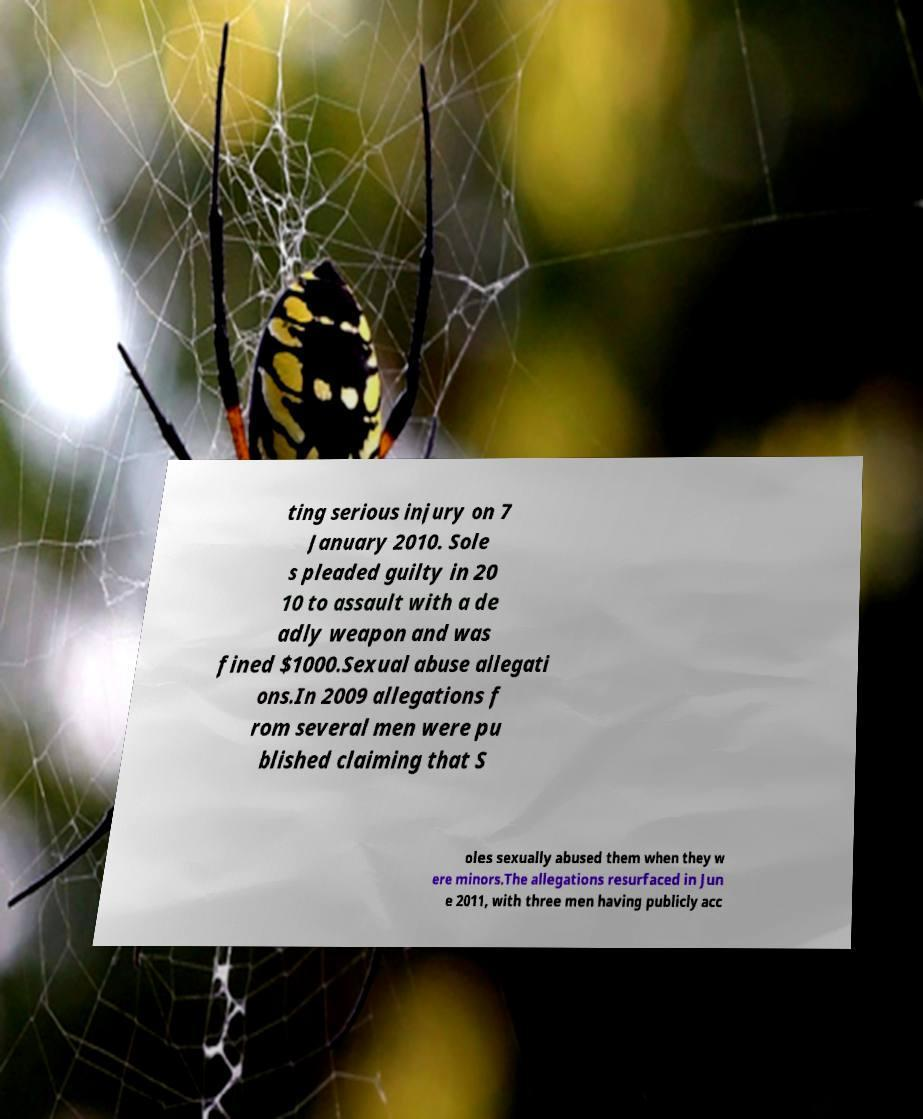I need the written content from this picture converted into text. Can you do that? ting serious injury on 7 January 2010. Sole s pleaded guilty in 20 10 to assault with a de adly weapon and was fined $1000.Sexual abuse allegati ons.In 2009 allegations f rom several men were pu blished claiming that S oles sexually abused them when they w ere minors.The allegations resurfaced in Jun e 2011, with three men having publicly acc 